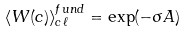Convert formula to latex. <formula><loc_0><loc_0><loc_500><loc_500>\langle W ( c ) \rangle _ { c \ell } ^ { f u n d } = \exp ( - \sigma A )</formula> 